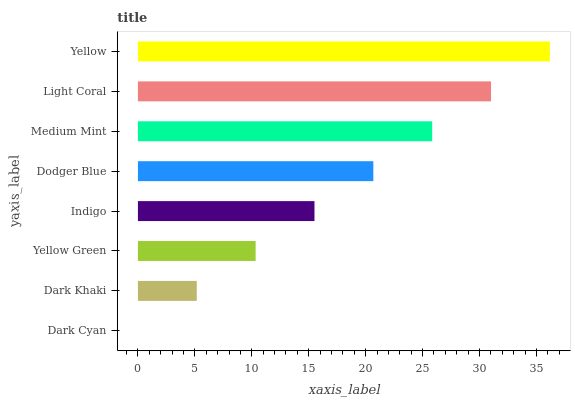Is Dark Cyan the minimum?
Answer yes or no. Yes. Is Yellow the maximum?
Answer yes or no. Yes. Is Dark Khaki the minimum?
Answer yes or no. No. Is Dark Khaki the maximum?
Answer yes or no. No. Is Dark Khaki greater than Dark Cyan?
Answer yes or no. Yes. Is Dark Cyan less than Dark Khaki?
Answer yes or no. Yes. Is Dark Cyan greater than Dark Khaki?
Answer yes or no. No. Is Dark Khaki less than Dark Cyan?
Answer yes or no. No. Is Dodger Blue the high median?
Answer yes or no. Yes. Is Indigo the low median?
Answer yes or no. Yes. Is Light Coral the high median?
Answer yes or no. No. Is Yellow Green the low median?
Answer yes or no. No. 